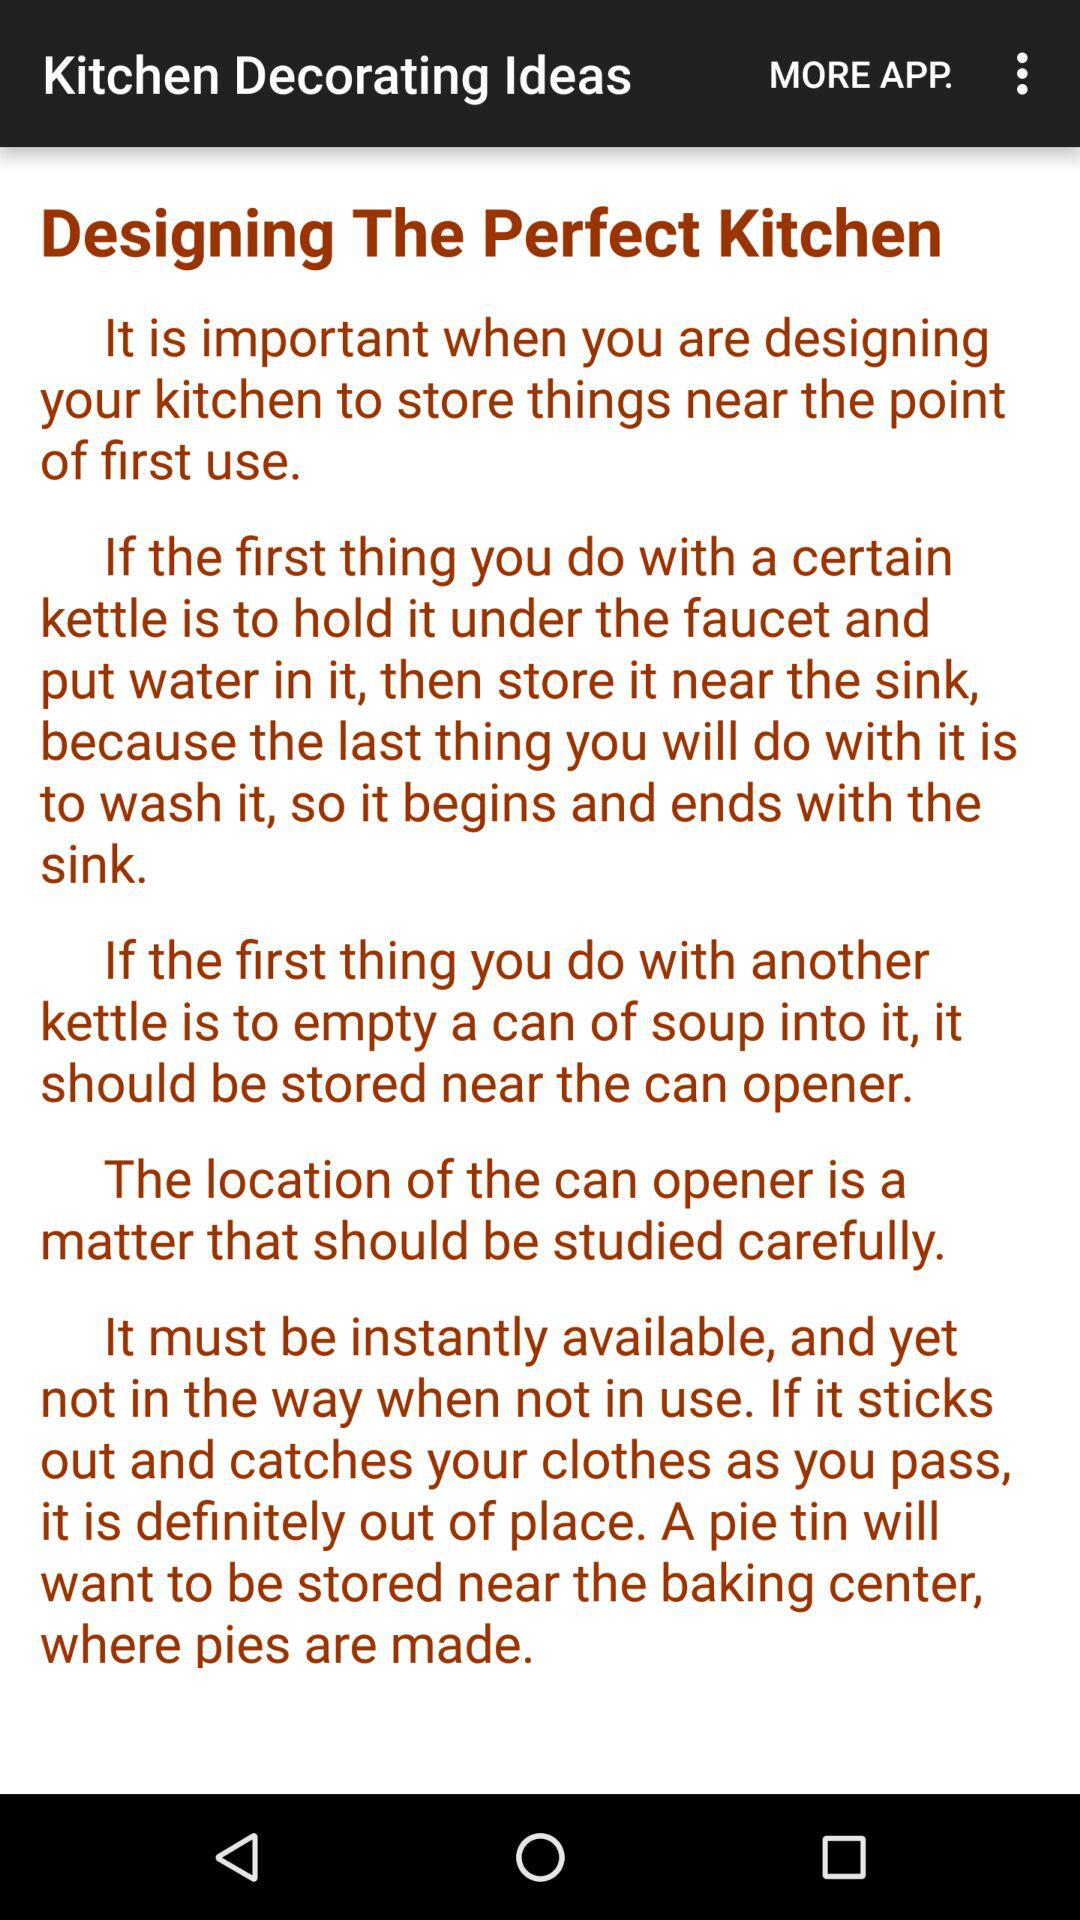How many sentences are there in the article?
Answer the question using a single word or phrase. 5 